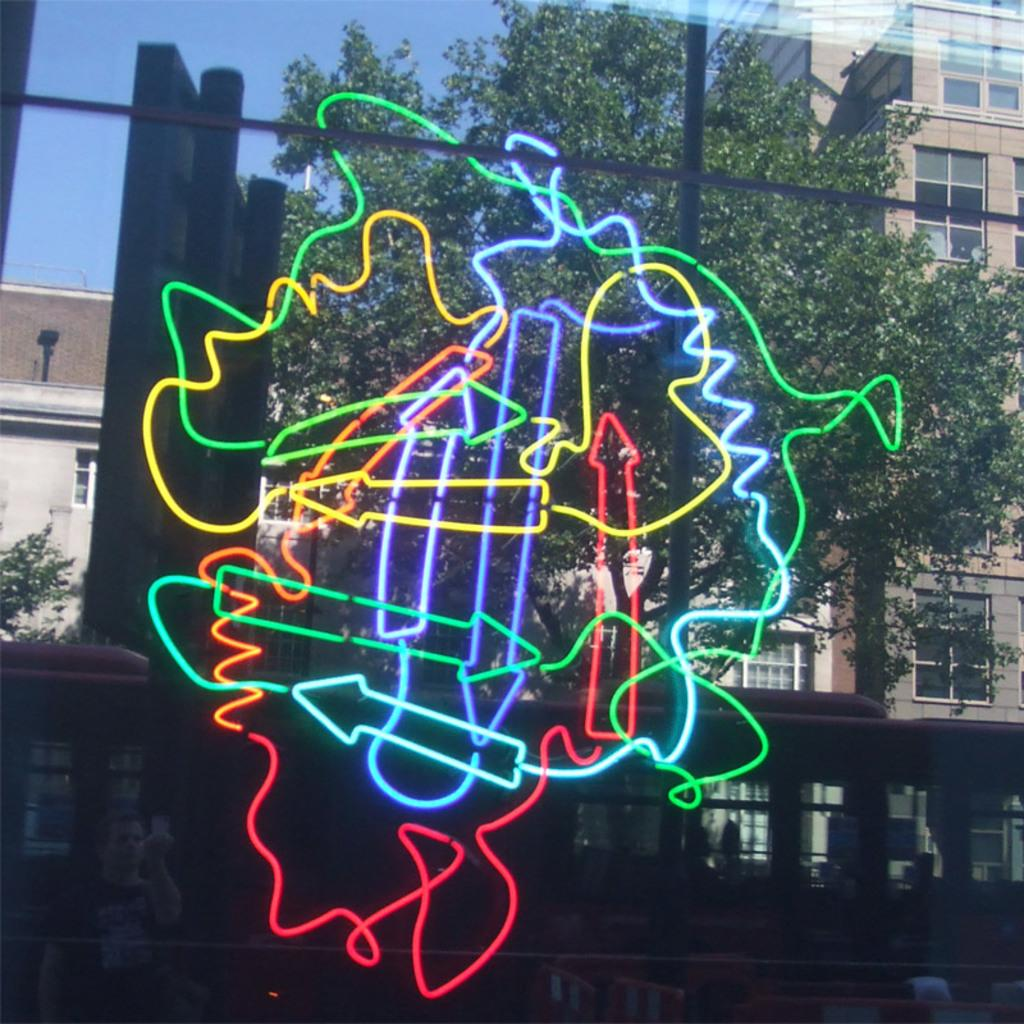What is the main object with different colors in the image? There is an object with different colors in the image, but the specific object is not mentioned in the facts. What can be seen in the background of the image? In the background of the image, there is a vehicle, a tree, and buildings. How many different elements can be seen in the background? There are three different elements in the background: a vehicle, a tree, and buildings. What type of wax is being used to create the branches in the image? There is no wax or branches present in the image. How much waste is visible in the image? There is no mention of waste in the image, so it cannot be determined from the facts. 